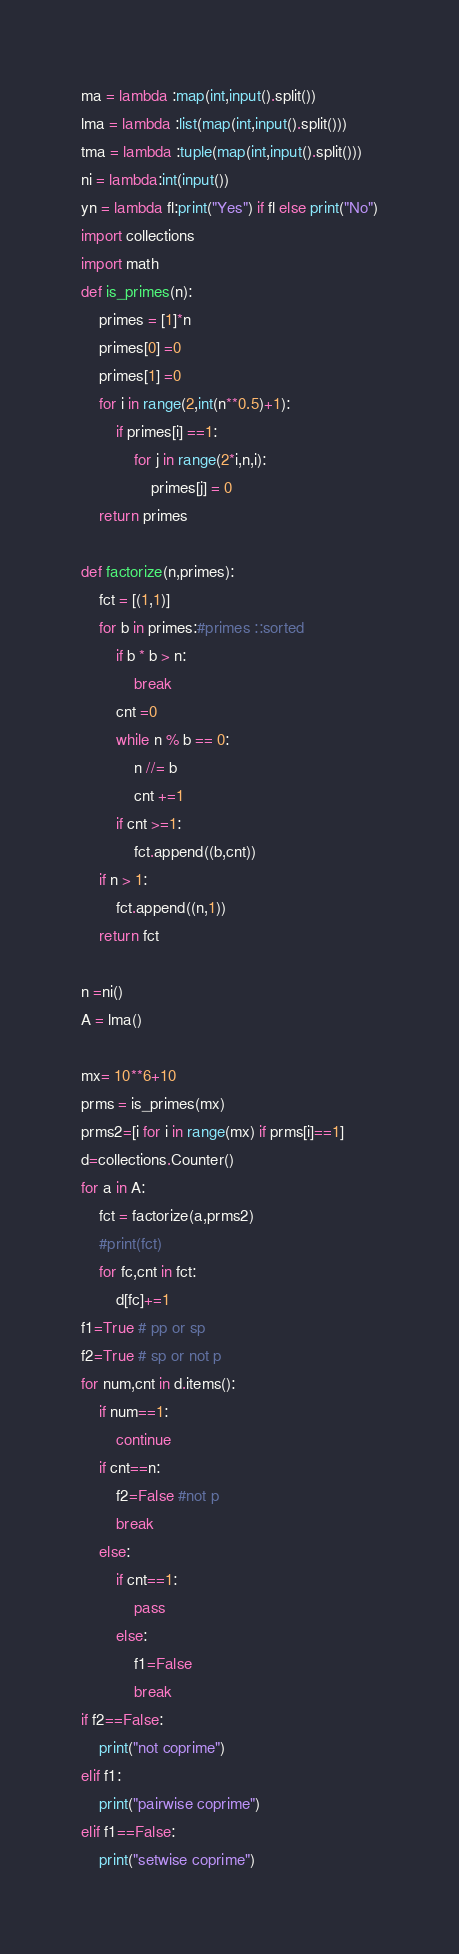<code> <loc_0><loc_0><loc_500><loc_500><_Python_>ma = lambda :map(int,input().split())
lma = lambda :list(map(int,input().split()))
tma = lambda :tuple(map(int,input().split()))
ni = lambda:int(input())
yn = lambda fl:print("Yes") if fl else print("No")
import collections
import math
def is_primes(n):
    primes = [1]*n
    primes[0] =0
    primes[1] =0
    for i in range(2,int(n**0.5)+1):
        if primes[i] ==1:
            for j in range(2*i,n,i):
                primes[j] = 0
    return primes

def factorize(n,primes):
    fct = [(1,1)]
    for b in primes:#primes ::sorted
        if b * b > n:
            break
        cnt =0
        while n % b == 0:
            n //= b
            cnt +=1
        if cnt >=1:
            fct.append((b,cnt))
    if n > 1:
        fct.append((n,1))
    return fct

n =ni()
A = lma()

mx= 10**6+10
prms = is_primes(mx)
prms2=[i for i in range(mx) if prms[i]==1]
d=collections.Counter()
for a in A:
    fct = factorize(a,prms2)
    #print(fct)
    for fc,cnt in fct:
        d[fc]+=1
f1=True # pp or sp
f2=True # sp or not p
for num,cnt in d.items():
    if num==1:
        continue
    if cnt==n:
        f2=False #not p
        break
    else:
        if cnt==1:
            pass
        else:
            f1=False
            break
if f2==False:
    print("not coprime")
elif f1:
    print("pairwise coprime")
elif f1==False:
    print("setwise coprime")
</code> 